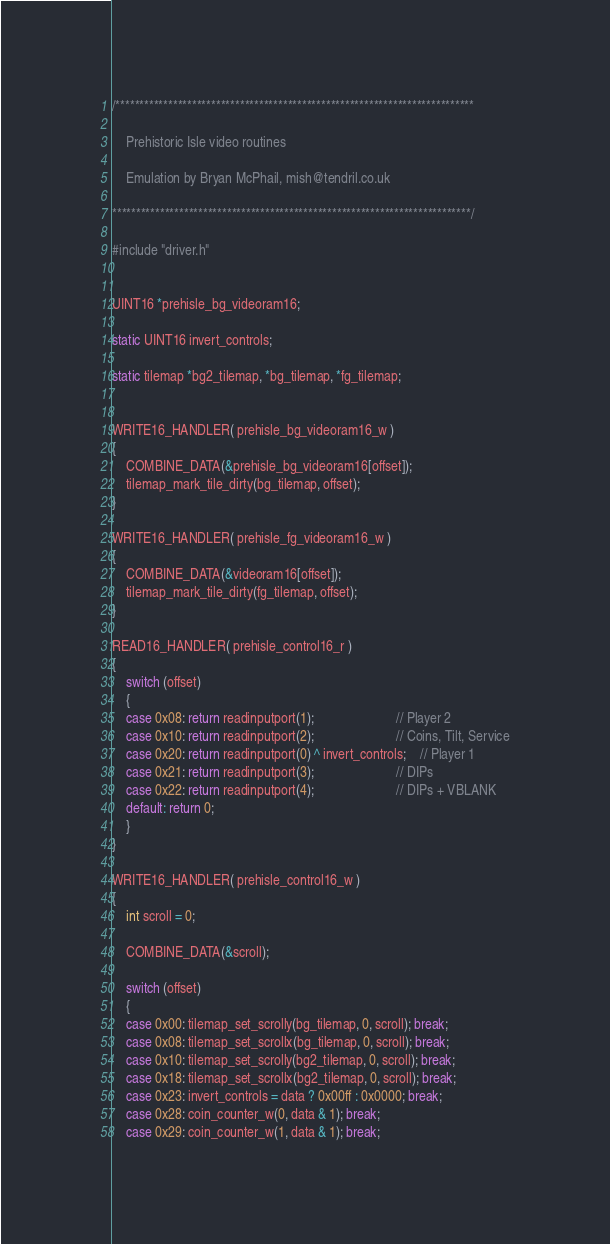Convert code to text. <code><loc_0><loc_0><loc_500><loc_500><_C_>/***************************************************************************

    Prehistoric Isle video routines

    Emulation by Bryan McPhail, mish@tendril.co.uk

***************************************************************************/

#include "driver.h"


UINT16 *prehisle_bg_videoram16;

static UINT16 invert_controls;

static tilemap *bg2_tilemap, *bg_tilemap, *fg_tilemap;


WRITE16_HANDLER( prehisle_bg_videoram16_w )
{
	COMBINE_DATA(&prehisle_bg_videoram16[offset]);
	tilemap_mark_tile_dirty(bg_tilemap, offset);
}

WRITE16_HANDLER( prehisle_fg_videoram16_w )
{
	COMBINE_DATA(&videoram16[offset]);
	tilemap_mark_tile_dirty(fg_tilemap, offset);
}

READ16_HANDLER( prehisle_control16_r )
{
	switch (offset)
	{
	case 0x08: return readinputport(1);						// Player 2
	case 0x10: return readinputport(2);						// Coins, Tilt, Service
	case 0x20: return readinputport(0) ^ invert_controls;	// Player 1
	case 0x21: return readinputport(3);						// DIPs
	case 0x22: return readinputport(4);						// DIPs + VBLANK
	default: return 0;
	}
}

WRITE16_HANDLER( prehisle_control16_w )
{
	int scroll = 0;

	COMBINE_DATA(&scroll);

	switch (offset)
	{
	case 0x00: tilemap_set_scrolly(bg_tilemap, 0, scroll); break;
	case 0x08: tilemap_set_scrollx(bg_tilemap, 0, scroll); break;
	case 0x10: tilemap_set_scrolly(bg2_tilemap, 0, scroll); break;
	case 0x18: tilemap_set_scrollx(bg2_tilemap, 0, scroll); break;
	case 0x23: invert_controls = data ? 0x00ff : 0x0000; break;
	case 0x28: coin_counter_w(0, data & 1); break;
	case 0x29: coin_counter_w(1, data & 1); break;</code> 